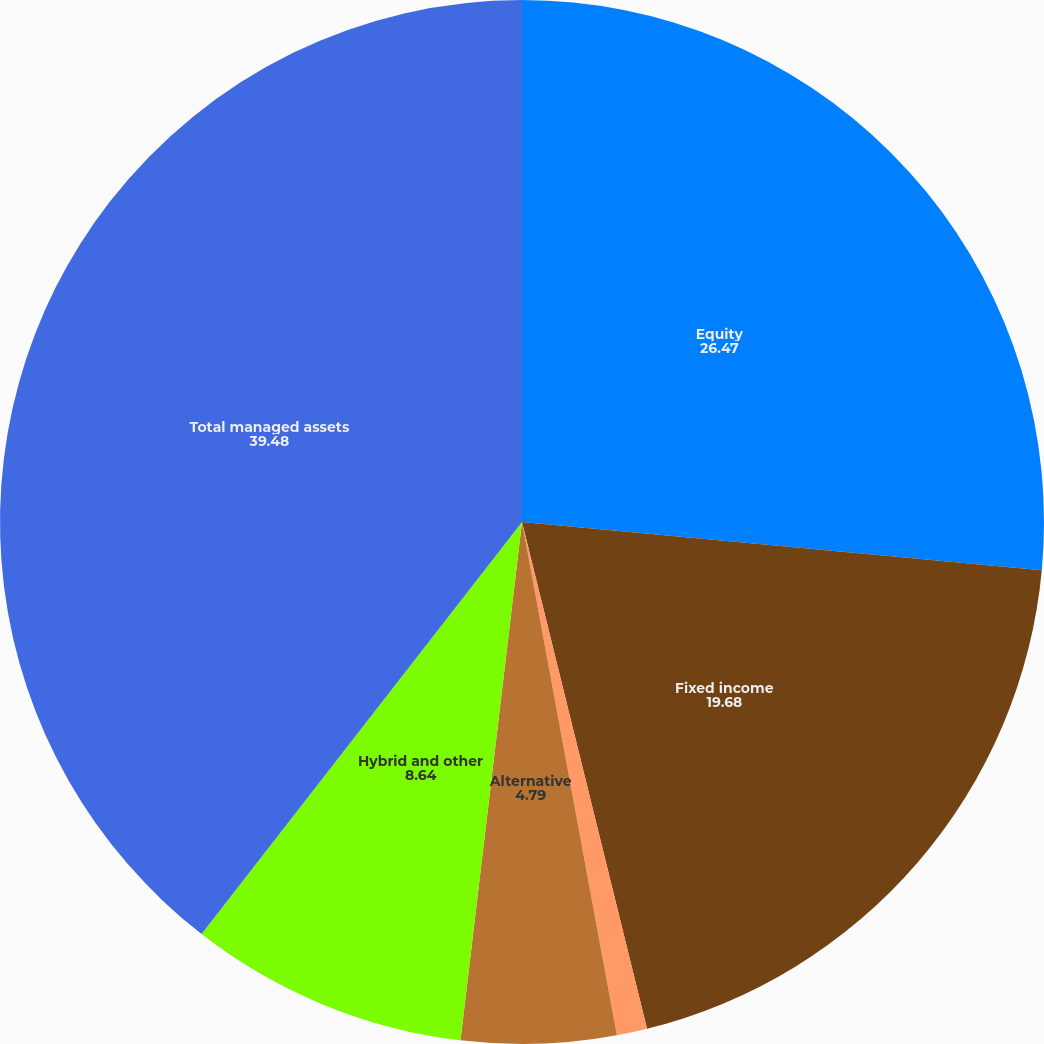Convert chart. <chart><loc_0><loc_0><loc_500><loc_500><pie_chart><fcel>Equity<fcel>Fixed income<fcel>Money market<fcel>Alternative<fcel>Hybrid and other<fcel>Total managed assets<nl><fcel>26.47%<fcel>19.68%<fcel>0.94%<fcel>4.79%<fcel>8.64%<fcel>39.48%<nl></chart> 